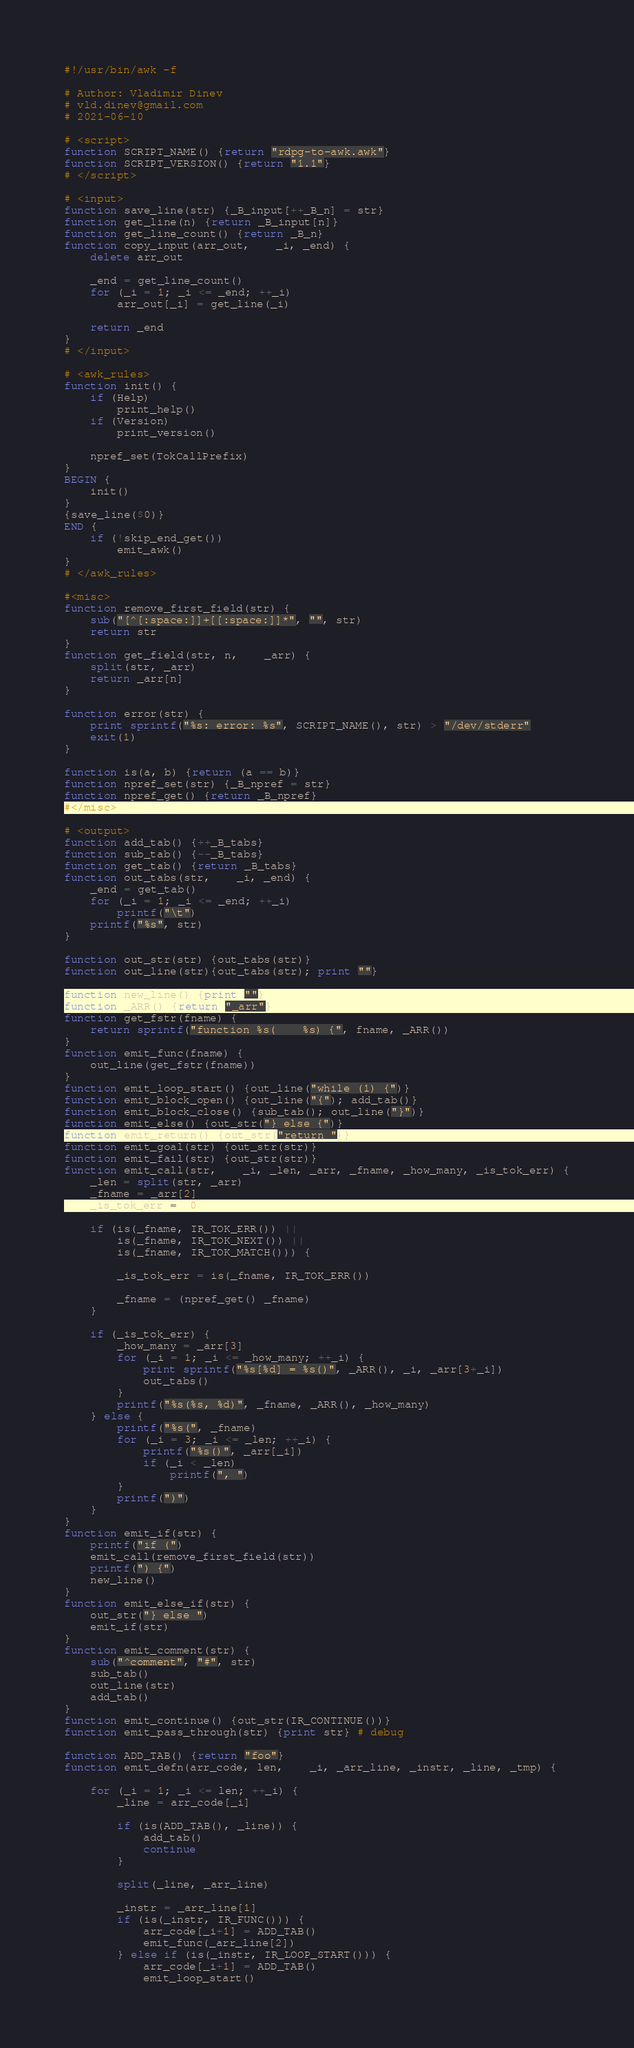Convert code to text. <code><loc_0><loc_0><loc_500><loc_500><_Awk_>#!/usr/bin/awk -f

# Author: Vladimir Dinev
# vld.dinev@gmail.com
# 2021-06-10

# <script>
function SCRIPT_NAME() {return "rdpg-to-awk.awk"}
function SCRIPT_VERSION() {return "1.1"}
# </script>

# <input>
function save_line(str) {_B_input[++_B_n] = str}
function get_line(n) {return _B_input[n]}
function get_line_count() {return _B_n}
function copy_input(arr_out,    _i, _end) {
	delete arr_out
	
	_end = get_line_count()
	for (_i = 1; _i <= _end; ++_i)
		arr_out[_i] = get_line(_i)
	
	return _end
}
# </input>

# <awk_rules>
function init() {
	if (Help)
		print_help()
	if (Version)
		print_version()
		
	npref_set(TokCallPrefix)
}
BEGIN {
	init()
}
{save_line($0)}
END {
	if (!skip_end_get())
		emit_awk()
}
# </awk_rules>

#<misc>
function remove_first_field(str) {
	sub("[^[:space:]]+[[:space:]]*", "", str)
	return str
}
function get_field(str, n,    _arr) {
	split(str, _arr)
	return _arr[n]
}

function error(str) {
	print sprintf("%s: error: %s", SCRIPT_NAME(), str) > "/dev/stderr"
	exit(1)
}

function is(a, b) {return (a == b)}
function npref_set(str) {_B_npref = str}
function npref_get() {return _B_npref}
#</misc>

# <output>
function add_tab() {++_B_tabs}
function sub_tab() {--_B_tabs}
function get_tab() {return _B_tabs}
function out_tabs(str,    _i, _end) {
	_end = get_tab()
	for (_i = 1; _i <= _end; ++_i)
		printf("\t")
	printf("%s", str)
}

function out_str(str) {out_tabs(str)}
function out_line(str){out_tabs(str); print ""}

function new_line() {print ""}
function _ARR() {return "_arr"}
function get_fstr(fname) {
	return sprintf("function %s(    %s) {", fname, _ARR())
}
function emit_func(fname) {
	out_line(get_fstr(fname))
}
function emit_loop_start() {out_line("while (1) {")}
function emit_block_open() {out_line("{"); add_tab()}
function emit_block_close() {sub_tab(); out_line("}")}
function emit_else() {out_str("} else {")}
function emit_return() {out_str("return ")}
function emit_goal(str) {out_str(str)}
function emit_fail(str) {out_str(str)}
function emit_call(str,    _i, _len, _arr, _fname, _how_many, _is_tok_err) {
	_len = split(str, _arr)
	_fname = _arr[2]
	_is_tok_err =  0

	if (is(_fname, IR_TOK_ERR()) ||
		is(_fname, IR_TOK_NEXT()) ||
		is(_fname, IR_TOK_MATCH())) {

		_is_tok_err = is(_fname, IR_TOK_ERR())

		_fname = (npref_get() _fname)
	}
	
	if (_is_tok_err) {
		_how_many = _arr[3]
		for (_i = 1; _i <= _how_many; ++_i) {
			print sprintf("%s[%d] = %s()", _ARR(), _i, _arr[3+_i])
			out_tabs()
		}
		printf("%s(%s, %d)", _fname, _ARR(), _how_many)
	} else {
		printf("%s(", _fname)
		for (_i = 3; _i <= _len; ++_i) {
			printf("%s()", _arr[_i])
			if (_i < _len)
				printf(", ")
		}
		printf(")")
	}
}
function emit_if(str) {
	printf("if (")
	emit_call(remove_first_field(str))
	printf(") {")
	new_line()
}
function emit_else_if(str) {
	out_str("} else ")
	emit_if(str)
}
function emit_comment(str) {
	sub("^comment", "#", str)
	sub_tab()
	out_line(str)
	add_tab()
}
function emit_continue() {out_str(IR_CONTINUE())}
function emit_pass_through(str) {print str} # debug

function ADD_TAB() {return "foo"}
function emit_defn(arr_code, len,    _i, _arr_line, _instr, _line, _tmp) {
	
	for (_i = 1; _i <= len; ++_i) {
		_line = arr_code[_i]
		
		if (is(ADD_TAB(), _line)) {
			add_tab()
			continue
		} 
		
		split(_line, _arr_line)
		
		_instr = _arr_line[1]
		if (is(_instr, IR_FUNC())) {
			arr_code[_i+1] = ADD_TAB()
			emit_func(_arr_line[2])
		} else if (is(_instr, IR_LOOP_START())) {
			arr_code[_i+1] = ADD_TAB()
			emit_loop_start()</code> 